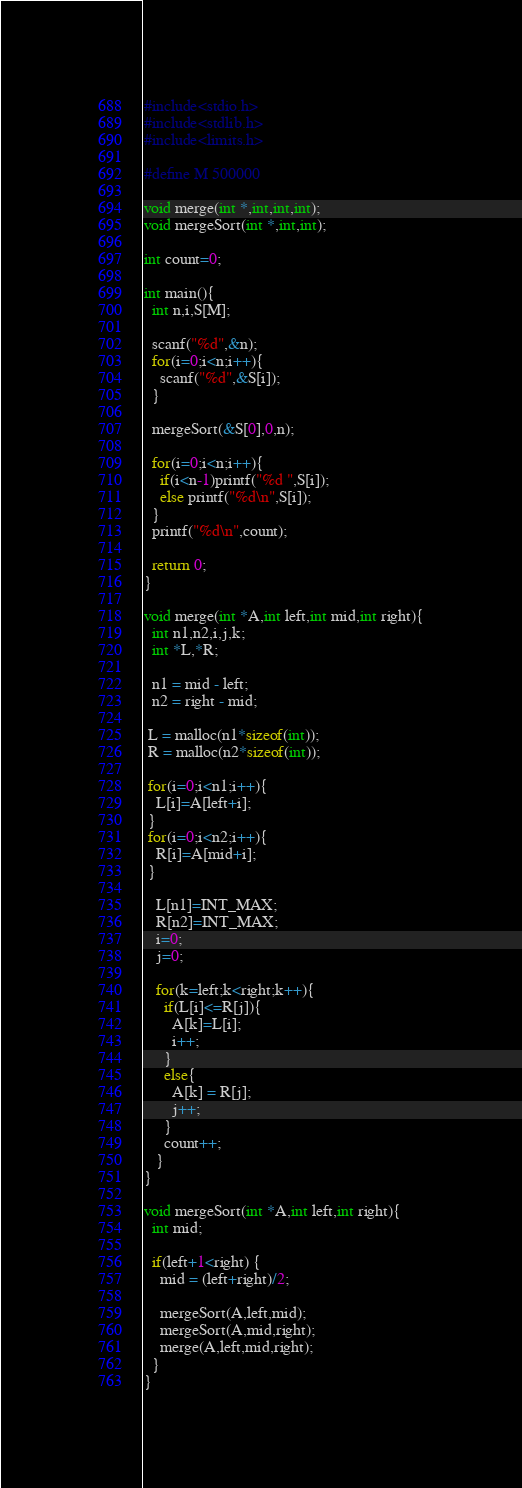Convert code to text. <code><loc_0><loc_0><loc_500><loc_500><_C_>#include<stdio.h>
#include<stdlib.h>
#include<limits.h>

#define M 500000

void merge(int *,int,int,int);
void mergeSort(int *,int,int);

int count=0;

int main(){
  int n,i,S[M];

  scanf("%d",&n);
  for(i=0;i<n;i++){
    scanf("%d",&S[i]);
  }

  mergeSort(&S[0],0,n);

  for(i=0;i<n;i++){
    if(i<n-1)printf("%d ",S[i]);
    else printf("%d\n",S[i]);
  }
  printf("%d\n",count);

  return 0;
}

void merge(int *A,int left,int mid,int right){
  int n1,n2,i,j,k;
  int *L,*R;

  n1 = mid - left;
  n2 = right - mid;

 L = malloc(n1*sizeof(int));
 R = malloc(n2*sizeof(int));

 for(i=0;i<n1;i++){
   L[i]=A[left+i];
 }
 for(i=0;i<n2;i++){
   R[i]=A[mid+i];
 }
 
   L[n1]=INT_MAX;
   R[n2]=INT_MAX;
   i=0;
   j=0;
 
   for(k=left;k<right;k++){
     if(L[i]<=R[j]){
       A[k]=L[i];
       i++;
     }
     else{
       A[k] = R[j];
       j++;
     }
     count++;
   }
}

void mergeSort(int *A,int left,int right){
  int mid;

  if(left+1<right) {
    mid = (left+right)/2;

    mergeSort(A,left,mid);
    mergeSort(A,mid,right);
    merge(A,left,mid,right);
  }
}</code> 